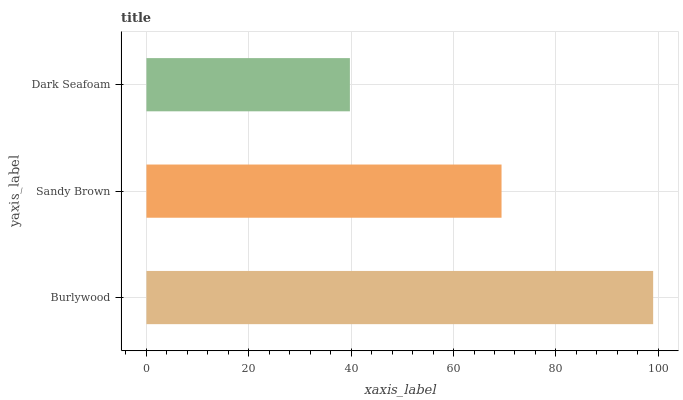Is Dark Seafoam the minimum?
Answer yes or no. Yes. Is Burlywood the maximum?
Answer yes or no. Yes. Is Sandy Brown the minimum?
Answer yes or no. No. Is Sandy Brown the maximum?
Answer yes or no. No. Is Burlywood greater than Sandy Brown?
Answer yes or no. Yes. Is Sandy Brown less than Burlywood?
Answer yes or no. Yes. Is Sandy Brown greater than Burlywood?
Answer yes or no. No. Is Burlywood less than Sandy Brown?
Answer yes or no. No. Is Sandy Brown the high median?
Answer yes or no. Yes. Is Sandy Brown the low median?
Answer yes or no. Yes. Is Dark Seafoam the high median?
Answer yes or no. No. Is Burlywood the low median?
Answer yes or no. No. 